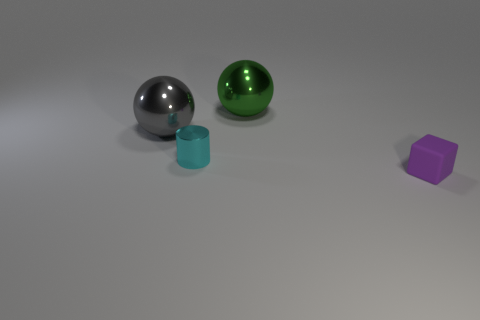Do the tiny metal thing and the big shiny object on the left side of the small cyan shiny cylinder have the same shape?
Your response must be concise. No. The large metallic sphere right of the metallic ball on the left side of the tiny object that is behind the purple object is what color?
Offer a very short reply. Green. What number of objects are either objects behind the small matte cube or large things in front of the big green thing?
Provide a succinct answer. 3. What number of other things are the same color as the tiny rubber block?
Ensure brevity in your answer.  0. Do the large object on the right side of the cyan object and the tiny cyan thing have the same shape?
Provide a succinct answer. No. Is the number of big green shiny balls that are on the left side of the big green ball less than the number of spheres?
Your answer should be very brief. Yes. Are there any gray balls made of the same material as the cylinder?
Ensure brevity in your answer.  Yes. There is another object that is the same size as the rubber object; what is its material?
Your answer should be very brief. Metal. Are there fewer cyan metallic things that are to the right of the small purple rubber object than large green balls that are right of the green metal thing?
Provide a short and direct response. No. There is a metal thing that is behind the tiny cyan metal thing and to the left of the green metal sphere; what is its shape?
Offer a terse response. Sphere. 